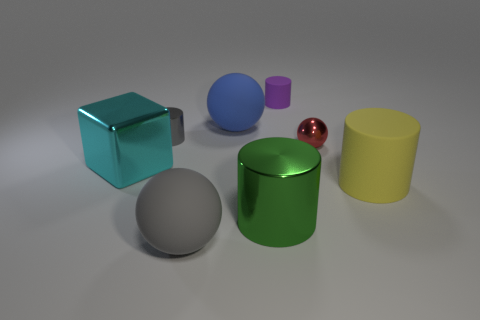What number of other things are the same color as the big shiny cylinder?
Make the answer very short. 0. Is the tiny ball the same color as the tiny rubber object?
Provide a succinct answer. No. What size is the object that is in front of the cylinder that is in front of the large yellow cylinder?
Provide a succinct answer. Large. Are the cylinder in front of the big yellow rubber thing and the cylinder right of the metallic sphere made of the same material?
Keep it short and to the point. No. There is a rubber cylinder that is behind the blue rubber object; does it have the same color as the big rubber cylinder?
Provide a short and direct response. No. There is a blue matte object; how many big yellow matte things are right of it?
Offer a terse response. 1. Are the large gray ball and the cylinder to the left of the large gray rubber ball made of the same material?
Offer a very short reply. No. What size is the cube that is made of the same material as the small gray object?
Your answer should be compact. Large. Are there more small gray objects that are behind the purple matte object than big rubber things to the left of the small gray metallic cylinder?
Your answer should be compact. No. Are there any large yellow metallic objects that have the same shape as the gray metal object?
Provide a succinct answer. No. 